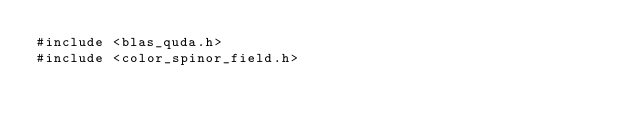Convert code to text. <code><loc_0><loc_0><loc_500><loc_500><_Cuda_>#include <blas_quda.h>
#include <color_spinor_field.h></code> 